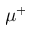Convert formula to latex. <formula><loc_0><loc_0><loc_500><loc_500>\mu ^ { + }</formula> 